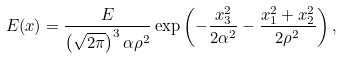<formula> <loc_0><loc_0><loc_500><loc_500>E ( { x } ) = \frac { E } { \left ( \sqrt { 2 \pi } \right ) ^ { 3 } \alpha \rho ^ { 2 } } \exp \left ( - \frac { x _ { 3 } ^ { 2 } } { 2 \alpha ^ { 2 } } - \frac { x _ { 1 } ^ { 2 } + x _ { 2 } ^ { 2 } } { 2 \rho ^ { 2 } } \right ) ,</formula> 